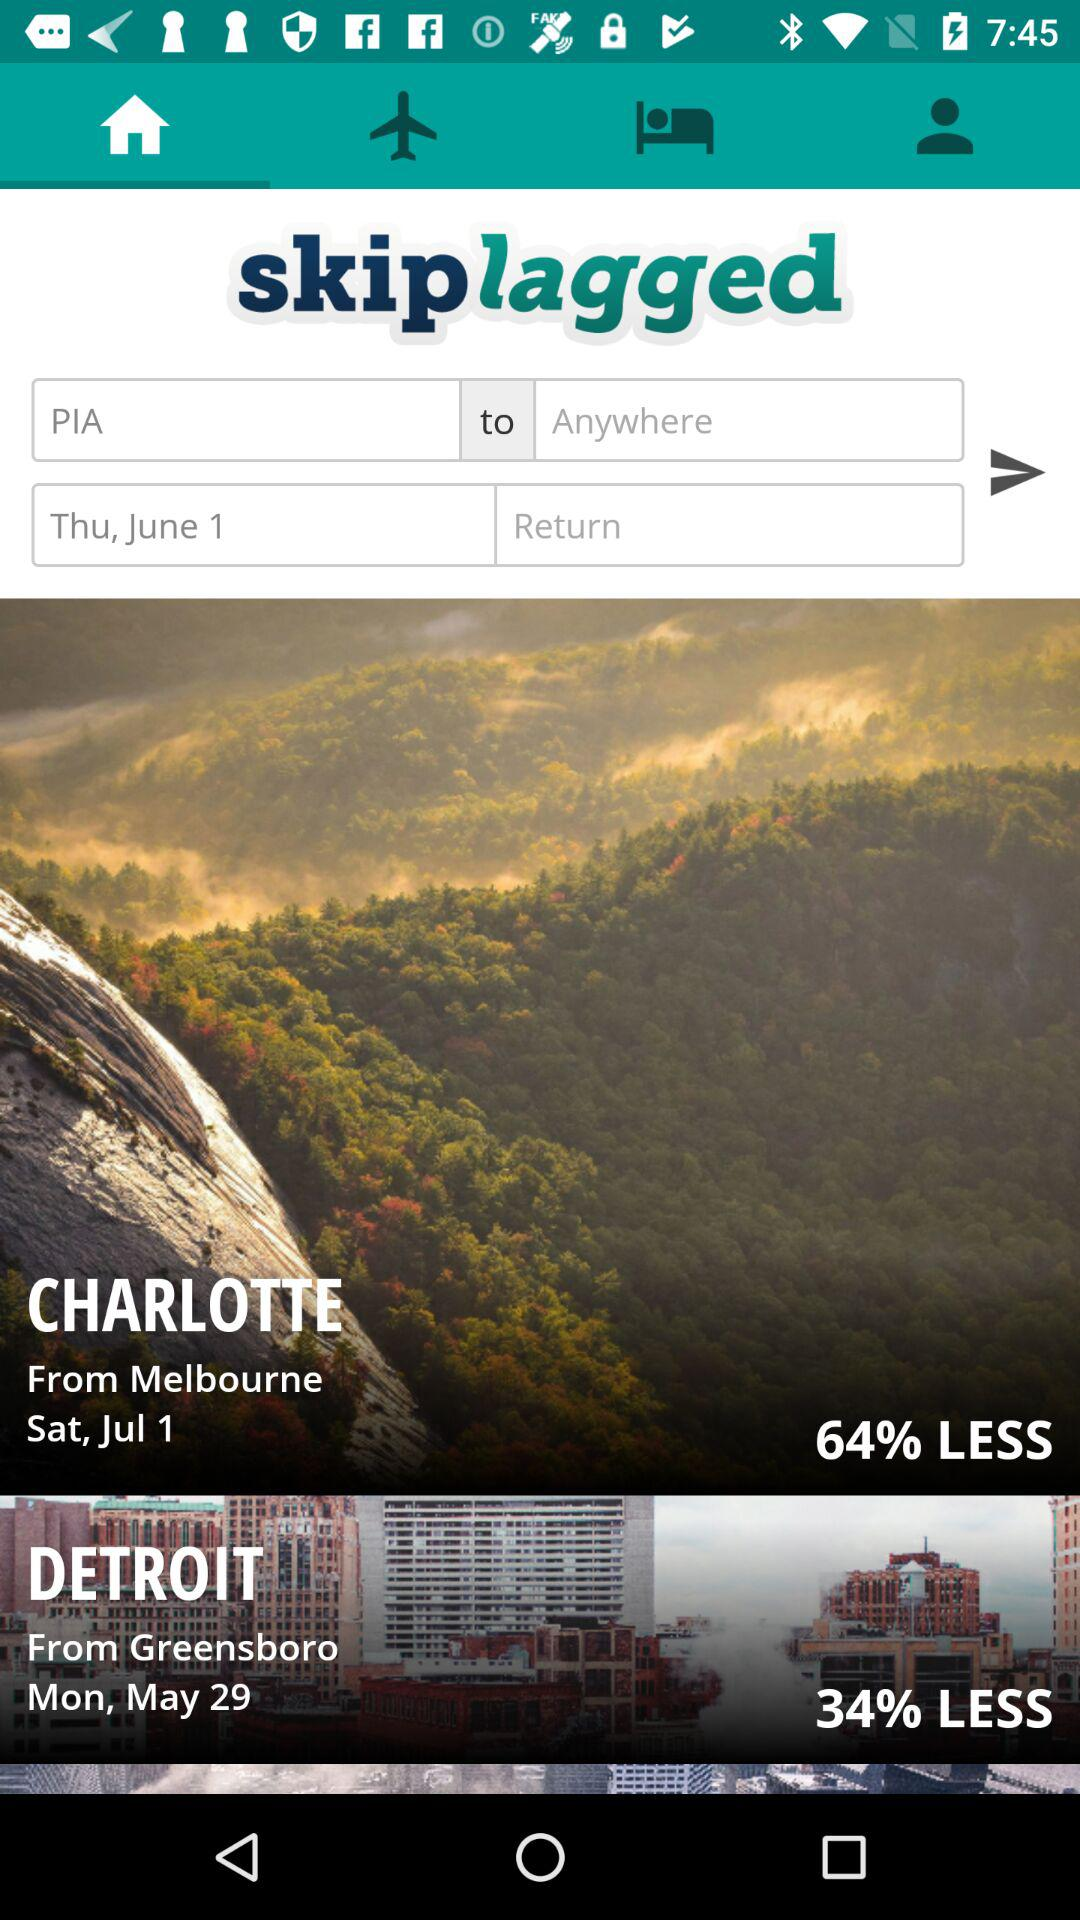What is the selected date? The selected date is Thursday, June 1. 